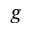Convert formula to latex. <formula><loc_0><loc_0><loc_500><loc_500>g</formula> 